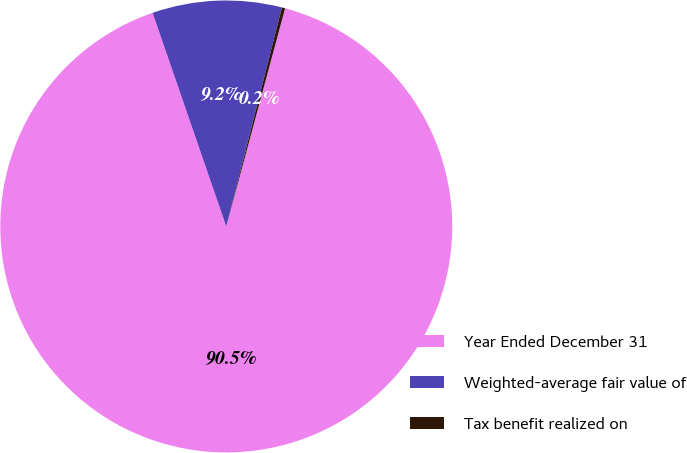<chart> <loc_0><loc_0><loc_500><loc_500><pie_chart><fcel>Year Ended December 31<fcel>Weighted-average fair value of<fcel>Tax benefit realized on<nl><fcel>90.52%<fcel>9.25%<fcel>0.23%<nl></chart> 